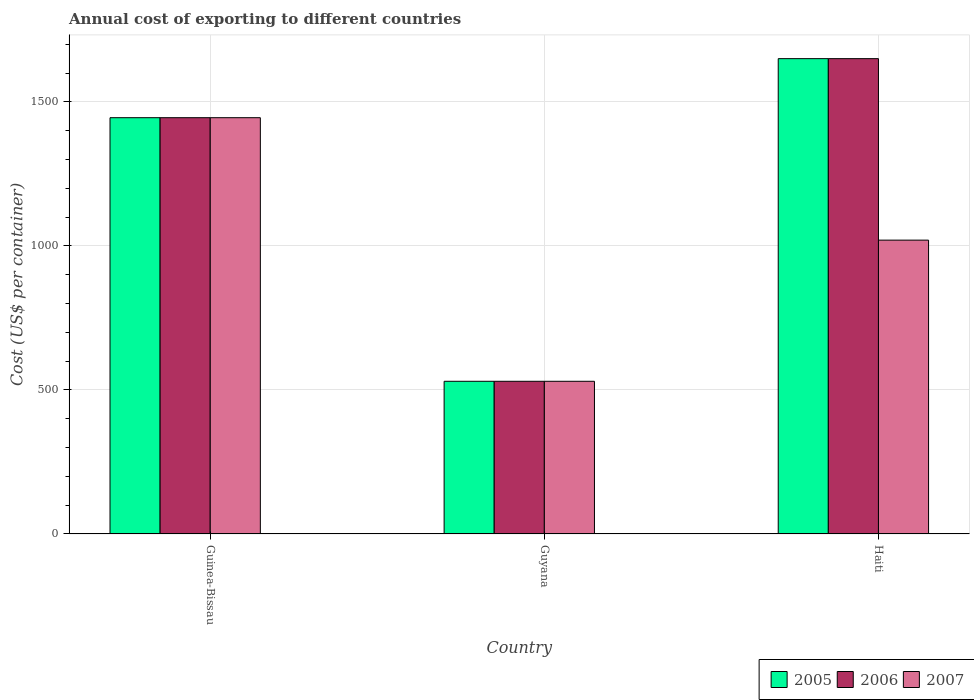How many different coloured bars are there?
Your answer should be very brief. 3. How many bars are there on the 1st tick from the left?
Ensure brevity in your answer.  3. How many bars are there on the 1st tick from the right?
Offer a terse response. 3. What is the label of the 1st group of bars from the left?
Your answer should be compact. Guinea-Bissau. In how many cases, is the number of bars for a given country not equal to the number of legend labels?
Keep it short and to the point. 0. What is the total annual cost of exporting in 2005 in Haiti?
Provide a short and direct response. 1650. Across all countries, what is the maximum total annual cost of exporting in 2007?
Provide a short and direct response. 1445. Across all countries, what is the minimum total annual cost of exporting in 2006?
Your answer should be very brief. 530. In which country was the total annual cost of exporting in 2005 maximum?
Your answer should be very brief. Haiti. In which country was the total annual cost of exporting in 2007 minimum?
Offer a very short reply. Guyana. What is the total total annual cost of exporting in 2006 in the graph?
Provide a succinct answer. 3625. What is the difference between the total annual cost of exporting in 2005 in Guinea-Bissau and that in Haiti?
Your answer should be very brief. -205. What is the difference between the total annual cost of exporting in 2005 in Haiti and the total annual cost of exporting in 2006 in Guyana?
Make the answer very short. 1120. What is the average total annual cost of exporting in 2007 per country?
Offer a very short reply. 998.33. What is the difference between the total annual cost of exporting of/in 2007 and total annual cost of exporting of/in 2005 in Haiti?
Ensure brevity in your answer.  -630. What is the ratio of the total annual cost of exporting in 2005 in Guinea-Bissau to that in Haiti?
Offer a very short reply. 0.88. Is the total annual cost of exporting in 2006 in Guyana less than that in Haiti?
Make the answer very short. Yes. What is the difference between the highest and the second highest total annual cost of exporting in 2007?
Your answer should be compact. -490. What is the difference between the highest and the lowest total annual cost of exporting in 2007?
Provide a short and direct response. 915. Is it the case that in every country, the sum of the total annual cost of exporting in 2006 and total annual cost of exporting in 2007 is greater than the total annual cost of exporting in 2005?
Keep it short and to the point. Yes. How many bars are there?
Your response must be concise. 9. What is the difference between two consecutive major ticks on the Y-axis?
Offer a very short reply. 500. Are the values on the major ticks of Y-axis written in scientific E-notation?
Your answer should be compact. No. What is the title of the graph?
Your answer should be very brief. Annual cost of exporting to different countries. What is the label or title of the X-axis?
Give a very brief answer. Country. What is the label or title of the Y-axis?
Give a very brief answer. Cost (US$ per container). What is the Cost (US$ per container) in 2005 in Guinea-Bissau?
Offer a terse response. 1445. What is the Cost (US$ per container) in 2006 in Guinea-Bissau?
Give a very brief answer. 1445. What is the Cost (US$ per container) of 2007 in Guinea-Bissau?
Give a very brief answer. 1445. What is the Cost (US$ per container) of 2005 in Guyana?
Your answer should be very brief. 530. What is the Cost (US$ per container) of 2006 in Guyana?
Your answer should be compact. 530. What is the Cost (US$ per container) of 2007 in Guyana?
Keep it short and to the point. 530. What is the Cost (US$ per container) of 2005 in Haiti?
Provide a succinct answer. 1650. What is the Cost (US$ per container) of 2006 in Haiti?
Keep it short and to the point. 1650. What is the Cost (US$ per container) in 2007 in Haiti?
Keep it short and to the point. 1020. Across all countries, what is the maximum Cost (US$ per container) of 2005?
Provide a succinct answer. 1650. Across all countries, what is the maximum Cost (US$ per container) in 2006?
Ensure brevity in your answer.  1650. Across all countries, what is the maximum Cost (US$ per container) of 2007?
Offer a very short reply. 1445. Across all countries, what is the minimum Cost (US$ per container) of 2005?
Provide a short and direct response. 530. Across all countries, what is the minimum Cost (US$ per container) in 2006?
Offer a very short reply. 530. Across all countries, what is the minimum Cost (US$ per container) of 2007?
Your answer should be compact. 530. What is the total Cost (US$ per container) in 2005 in the graph?
Your answer should be very brief. 3625. What is the total Cost (US$ per container) of 2006 in the graph?
Your response must be concise. 3625. What is the total Cost (US$ per container) of 2007 in the graph?
Your answer should be very brief. 2995. What is the difference between the Cost (US$ per container) in 2005 in Guinea-Bissau and that in Guyana?
Provide a short and direct response. 915. What is the difference between the Cost (US$ per container) of 2006 in Guinea-Bissau and that in Guyana?
Ensure brevity in your answer.  915. What is the difference between the Cost (US$ per container) of 2007 in Guinea-Bissau and that in Guyana?
Give a very brief answer. 915. What is the difference between the Cost (US$ per container) in 2005 in Guinea-Bissau and that in Haiti?
Provide a succinct answer. -205. What is the difference between the Cost (US$ per container) in 2006 in Guinea-Bissau and that in Haiti?
Ensure brevity in your answer.  -205. What is the difference between the Cost (US$ per container) of 2007 in Guinea-Bissau and that in Haiti?
Give a very brief answer. 425. What is the difference between the Cost (US$ per container) of 2005 in Guyana and that in Haiti?
Ensure brevity in your answer.  -1120. What is the difference between the Cost (US$ per container) of 2006 in Guyana and that in Haiti?
Offer a terse response. -1120. What is the difference between the Cost (US$ per container) in 2007 in Guyana and that in Haiti?
Your answer should be very brief. -490. What is the difference between the Cost (US$ per container) in 2005 in Guinea-Bissau and the Cost (US$ per container) in 2006 in Guyana?
Make the answer very short. 915. What is the difference between the Cost (US$ per container) of 2005 in Guinea-Bissau and the Cost (US$ per container) of 2007 in Guyana?
Your response must be concise. 915. What is the difference between the Cost (US$ per container) in 2006 in Guinea-Bissau and the Cost (US$ per container) in 2007 in Guyana?
Keep it short and to the point. 915. What is the difference between the Cost (US$ per container) of 2005 in Guinea-Bissau and the Cost (US$ per container) of 2006 in Haiti?
Provide a succinct answer. -205. What is the difference between the Cost (US$ per container) of 2005 in Guinea-Bissau and the Cost (US$ per container) of 2007 in Haiti?
Offer a terse response. 425. What is the difference between the Cost (US$ per container) of 2006 in Guinea-Bissau and the Cost (US$ per container) of 2007 in Haiti?
Give a very brief answer. 425. What is the difference between the Cost (US$ per container) in 2005 in Guyana and the Cost (US$ per container) in 2006 in Haiti?
Keep it short and to the point. -1120. What is the difference between the Cost (US$ per container) in 2005 in Guyana and the Cost (US$ per container) in 2007 in Haiti?
Keep it short and to the point. -490. What is the difference between the Cost (US$ per container) in 2006 in Guyana and the Cost (US$ per container) in 2007 in Haiti?
Provide a short and direct response. -490. What is the average Cost (US$ per container) in 2005 per country?
Provide a succinct answer. 1208.33. What is the average Cost (US$ per container) of 2006 per country?
Make the answer very short. 1208.33. What is the average Cost (US$ per container) of 2007 per country?
Your response must be concise. 998.33. What is the difference between the Cost (US$ per container) of 2005 and Cost (US$ per container) of 2006 in Guinea-Bissau?
Keep it short and to the point. 0. What is the difference between the Cost (US$ per container) in 2005 and Cost (US$ per container) in 2006 in Guyana?
Your response must be concise. 0. What is the difference between the Cost (US$ per container) of 2005 and Cost (US$ per container) of 2007 in Haiti?
Provide a succinct answer. 630. What is the difference between the Cost (US$ per container) in 2006 and Cost (US$ per container) in 2007 in Haiti?
Keep it short and to the point. 630. What is the ratio of the Cost (US$ per container) in 2005 in Guinea-Bissau to that in Guyana?
Give a very brief answer. 2.73. What is the ratio of the Cost (US$ per container) in 2006 in Guinea-Bissau to that in Guyana?
Ensure brevity in your answer.  2.73. What is the ratio of the Cost (US$ per container) in 2007 in Guinea-Bissau to that in Guyana?
Make the answer very short. 2.73. What is the ratio of the Cost (US$ per container) in 2005 in Guinea-Bissau to that in Haiti?
Offer a terse response. 0.88. What is the ratio of the Cost (US$ per container) of 2006 in Guinea-Bissau to that in Haiti?
Your answer should be compact. 0.88. What is the ratio of the Cost (US$ per container) in 2007 in Guinea-Bissau to that in Haiti?
Your response must be concise. 1.42. What is the ratio of the Cost (US$ per container) of 2005 in Guyana to that in Haiti?
Provide a succinct answer. 0.32. What is the ratio of the Cost (US$ per container) of 2006 in Guyana to that in Haiti?
Your answer should be compact. 0.32. What is the ratio of the Cost (US$ per container) of 2007 in Guyana to that in Haiti?
Provide a succinct answer. 0.52. What is the difference between the highest and the second highest Cost (US$ per container) of 2005?
Keep it short and to the point. 205. What is the difference between the highest and the second highest Cost (US$ per container) of 2006?
Your response must be concise. 205. What is the difference between the highest and the second highest Cost (US$ per container) in 2007?
Offer a very short reply. 425. What is the difference between the highest and the lowest Cost (US$ per container) in 2005?
Give a very brief answer. 1120. What is the difference between the highest and the lowest Cost (US$ per container) in 2006?
Make the answer very short. 1120. What is the difference between the highest and the lowest Cost (US$ per container) in 2007?
Your answer should be compact. 915. 